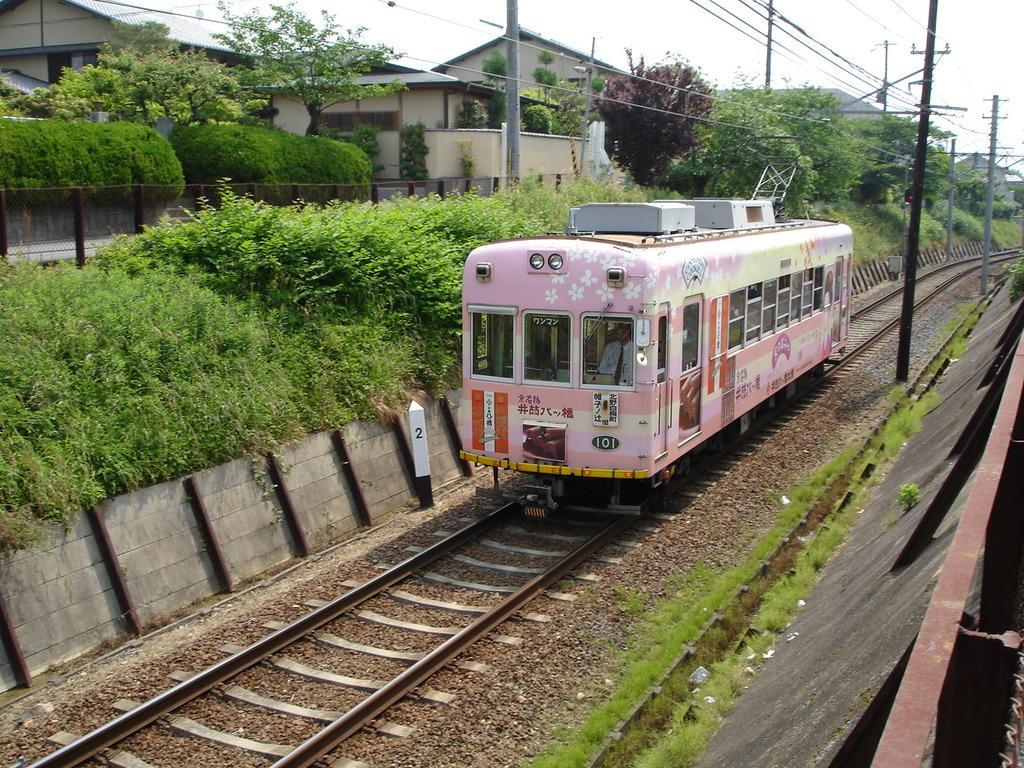Please provide a concise description of this image. In this image I can see a train , in the train I can see a person and I can see a railway track visible and i can see power line cables and poles visible in the middle , on the left side I can see a glass , bushes and trees and houses,at the top I can see the sky. 